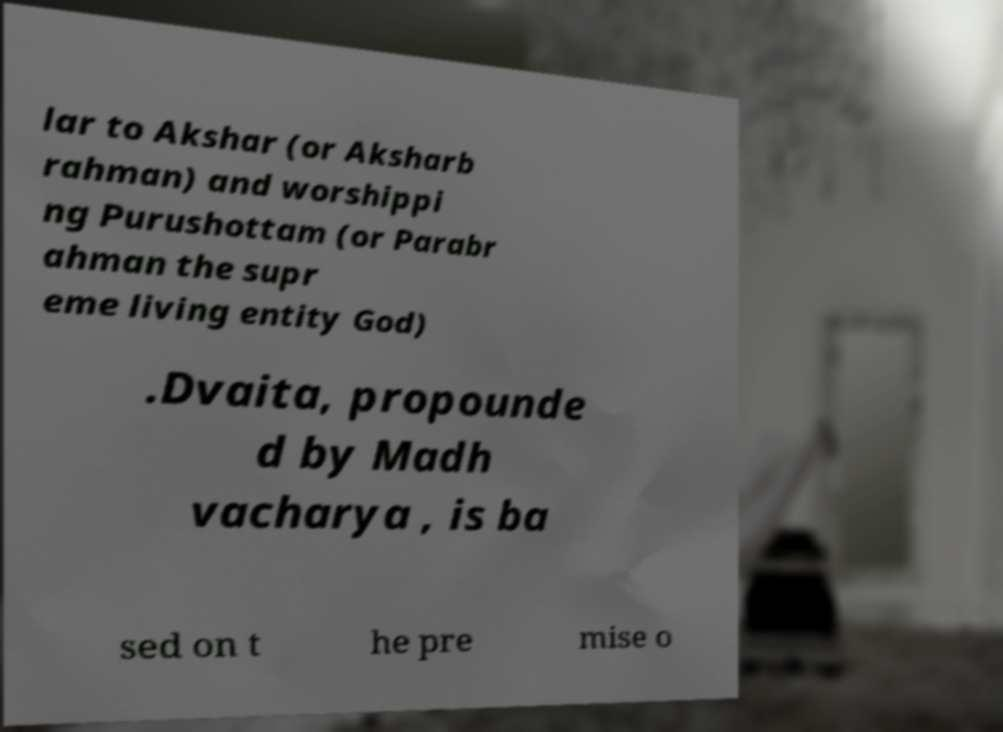Could you extract and type out the text from this image? lar to Akshar (or Aksharb rahman) and worshippi ng Purushottam (or Parabr ahman the supr eme living entity God) .Dvaita, propounde d by Madh vacharya , is ba sed on t he pre mise o 